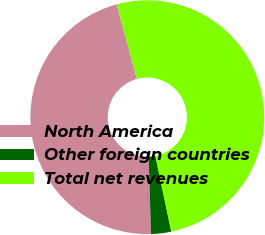Convert chart. <chart><loc_0><loc_0><loc_500><loc_500><pie_chart><fcel>North America<fcel>Other foreign countries<fcel>Total net revenues<nl><fcel>46.3%<fcel>2.77%<fcel>50.93%<nl></chart> 